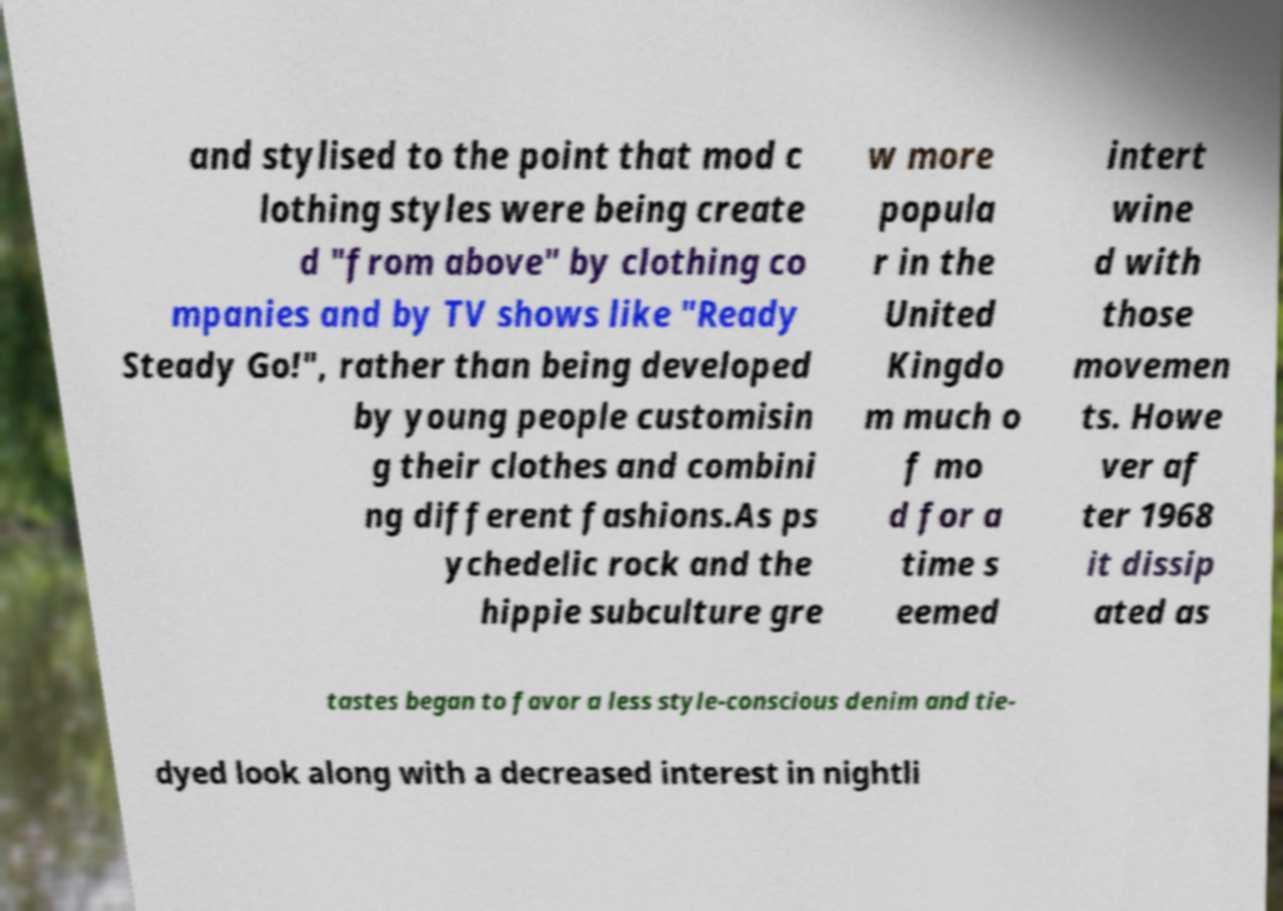Can you read and provide the text displayed in the image?This photo seems to have some interesting text. Can you extract and type it out for me? and stylised to the point that mod c lothing styles were being create d "from above" by clothing co mpanies and by TV shows like "Ready Steady Go!", rather than being developed by young people customisin g their clothes and combini ng different fashions.As ps ychedelic rock and the hippie subculture gre w more popula r in the United Kingdo m much o f mo d for a time s eemed intert wine d with those movemen ts. Howe ver af ter 1968 it dissip ated as tastes began to favor a less style-conscious denim and tie- dyed look along with a decreased interest in nightli 